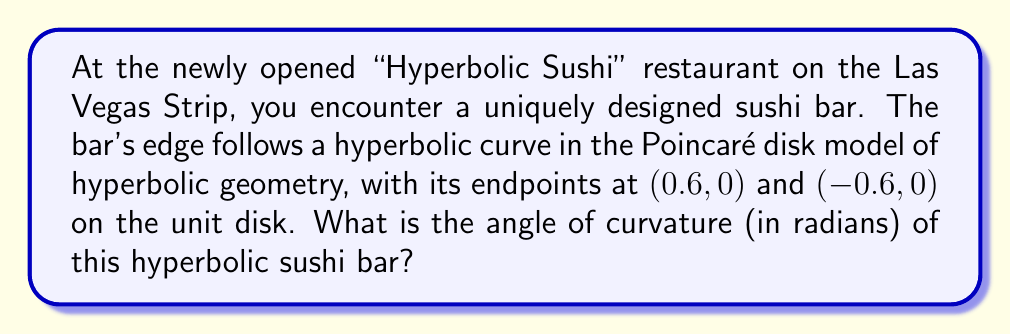Can you answer this question? To solve this problem, we'll follow these steps:

1) In the Poincaré disk model, hyperbolic lines are represented by circular arcs perpendicular to the boundary of the unit disk. The angle of curvature is twice the angle between the hyperbolic line and the boundary of the disk at the point of intersection.

2) First, we need to find the center and radius of the circle that contains our hyperbolic line. The general equation of a circle is:

   $$(x-h)^2 + (y-k)^2 = r^2$$

   where $(h,k)$ is the center and $r$ is the radius.

3) Since our hyperbolic line is symmetrical about the y-axis, its center must be on the y-axis. Let's say the center is at $(0,k)$. The circle passes through $(0.6, 0)$ and $(-0.6, 0)$, so:

   $$0.6^2 + k^2 = r^2$$

4) The circle must be perpendicular to the unit circle at these points. This means that the tangent to the circle at $(0.6, 0)$ must pass through the center of the unit circle $(0,0)$. The slope of the radius at this point is $k/0.6$, and the slope of the tangent (perpendicular to the radius) is $-0.6/k$. For the tangent to pass through $(0,0)$, we must have:

   $$\frac{-0.6}{k} = \frac{0 - 0}{0.6 - 0} = 0$$

   This is only true if $k$ approaches infinity.

5) As $k$ approaches infinity, our circle becomes a straight line. The equation of this line is simply $x = 0.6$.

6) The angle between this line and the unit circle at $(0.6, 0)$ is:

   $$\theta = \arccos(0.6)$$

7) The angle of curvature is twice this angle:

   $$\text{Angle of curvature} = 2\arccos(0.6)$$

[asy]
import geometry;

unitcircle();
draw((-0.6,0)--(0.6,0), blue);
draw((0.6,0)--(0.6,1), red);
label("$\theta$", (0.65,0.1), E);
dot((0.6,0));
dot((-0.6,0));
label("(0.6,0)", (0.6,-0.1), S);
label("(-0.6,0)", (-0.6,-0.1), S);
[/asy]
Answer: $2\arccos(0.6)$ radians 